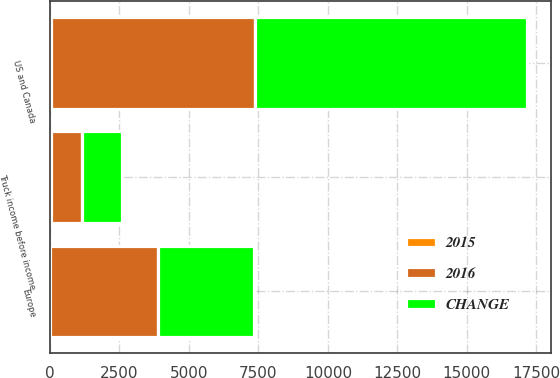Convert chart. <chart><loc_0><loc_0><loc_500><loc_500><stacked_bar_chart><ecel><fcel>US and Canada<fcel>Europe<fcel>Truck income before income<nl><fcel>2016<fcel>7363.5<fcel>3863<fcel>1125.8<nl><fcel>CHANGE<fcel>9774.3<fcel>3472.1<fcel>1440.3<nl><fcel>2015<fcel>25<fcel>11<fcel>22<nl></chart> 